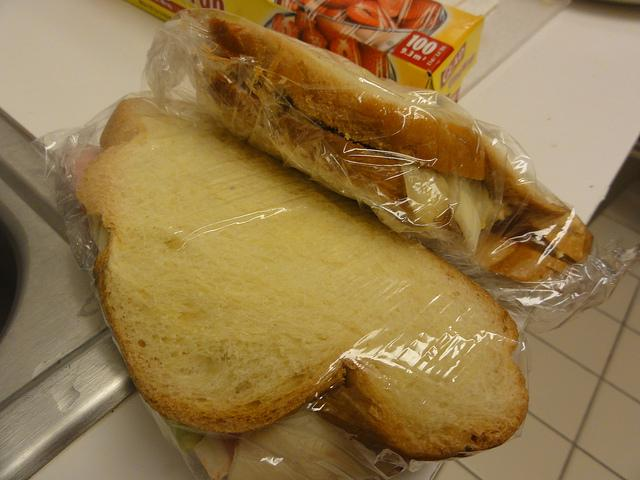What has made the sandwiches to look shiny?

Choices:
A) saran wrap
B) glass
C) icing
D) butter saran wrap 